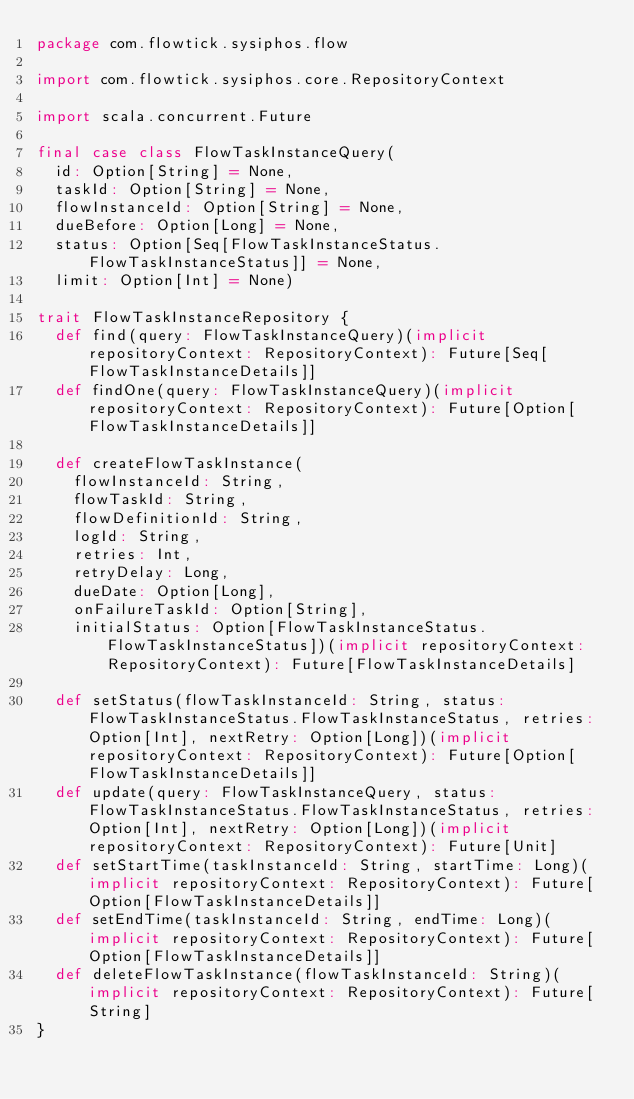<code> <loc_0><loc_0><loc_500><loc_500><_Scala_>package com.flowtick.sysiphos.flow

import com.flowtick.sysiphos.core.RepositoryContext

import scala.concurrent.Future

final case class FlowTaskInstanceQuery(
  id: Option[String] = None,
  taskId: Option[String] = None,
  flowInstanceId: Option[String] = None,
  dueBefore: Option[Long] = None,
  status: Option[Seq[FlowTaskInstanceStatus.FlowTaskInstanceStatus]] = None,
  limit: Option[Int] = None)

trait FlowTaskInstanceRepository {
  def find(query: FlowTaskInstanceQuery)(implicit repositoryContext: RepositoryContext): Future[Seq[FlowTaskInstanceDetails]]
  def findOne(query: FlowTaskInstanceQuery)(implicit repositoryContext: RepositoryContext): Future[Option[FlowTaskInstanceDetails]]

  def createFlowTaskInstance(
    flowInstanceId: String,
    flowTaskId: String,
    flowDefinitionId: String,
    logId: String,
    retries: Int,
    retryDelay: Long,
    dueDate: Option[Long],
    onFailureTaskId: Option[String],
    initialStatus: Option[FlowTaskInstanceStatus.FlowTaskInstanceStatus])(implicit repositoryContext: RepositoryContext): Future[FlowTaskInstanceDetails]

  def setStatus(flowTaskInstanceId: String, status: FlowTaskInstanceStatus.FlowTaskInstanceStatus, retries: Option[Int], nextRetry: Option[Long])(implicit repositoryContext: RepositoryContext): Future[Option[FlowTaskInstanceDetails]]
  def update(query: FlowTaskInstanceQuery, status: FlowTaskInstanceStatus.FlowTaskInstanceStatus, retries: Option[Int], nextRetry: Option[Long])(implicit repositoryContext: RepositoryContext): Future[Unit]
  def setStartTime(taskInstanceId: String, startTime: Long)(implicit repositoryContext: RepositoryContext): Future[Option[FlowTaskInstanceDetails]]
  def setEndTime(taskInstanceId: String, endTime: Long)(implicit repositoryContext: RepositoryContext): Future[Option[FlowTaskInstanceDetails]]
  def deleteFlowTaskInstance(flowTaskInstanceId: String)(implicit repositoryContext: RepositoryContext): Future[String]
}
</code> 